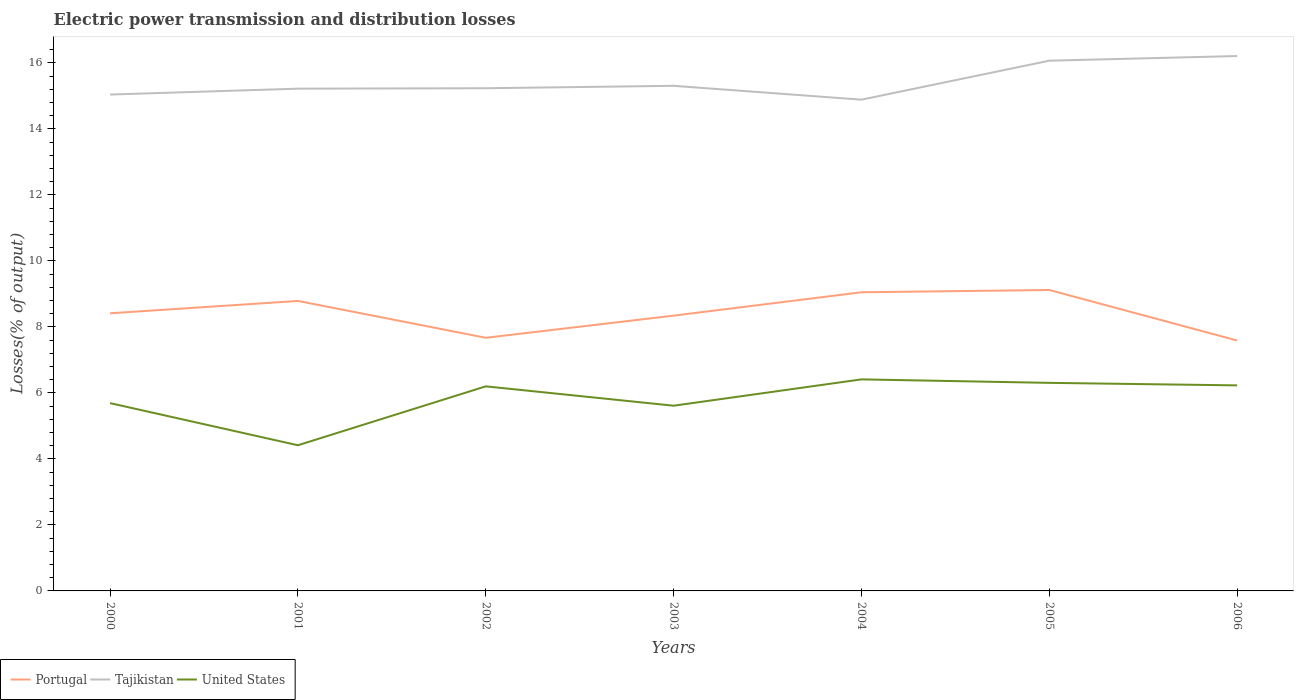Is the number of lines equal to the number of legend labels?
Ensure brevity in your answer.  Yes. Across all years, what is the maximum electric power transmission and distribution losses in United States?
Your answer should be compact. 4.41. What is the total electric power transmission and distribution losses in Portugal in the graph?
Your answer should be compact. -0.64. What is the difference between the highest and the second highest electric power transmission and distribution losses in Portugal?
Provide a succinct answer. 1.53. What is the difference between the highest and the lowest electric power transmission and distribution losses in Portugal?
Ensure brevity in your answer.  3. How many lines are there?
Your answer should be compact. 3. Does the graph contain any zero values?
Offer a terse response. No. Does the graph contain grids?
Ensure brevity in your answer.  No. Where does the legend appear in the graph?
Provide a succinct answer. Bottom left. How many legend labels are there?
Your answer should be very brief. 3. What is the title of the graph?
Provide a short and direct response. Electric power transmission and distribution losses. What is the label or title of the Y-axis?
Make the answer very short. Losses(% of output). What is the Losses(% of output) in Portugal in 2000?
Your answer should be compact. 8.41. What is the Losses(% of output) of Tajikistan in 2000?
Offer a very short reply. 15.04. What is the Losses(% of output) of United States in 2000?
Give a very brief answer. 5.69. What is the Losses(% of output) in Portugal in 2001?
Keep it short and to the point. 8.79. What is the Losses(% of output) in Tajikistan in 2001?
Provide a succinct answer. 15.22. What is the Losses(% of output) in United States in 2001?
Offer a very short reply. 4.41. What is the Losses(% of output) of Portugal in 2002?
Provide a succinct answer. 7.67. What is the Losses(% of output) of Tajikistan in 2002?
Keep it short and to the point. 15.23. What is the Losses(% of output) of United States in 2002?
Your response must be concise. 6.2. What is the Losses(% of output) of Portugal in 2003?
Your response must be concise. 8.34. What is the Losses(% of output) of Tajikistan in 2003?
Provide a succinct answer. 15.31. What is the Losses(% of output) of United States in 2003?
Your answer should be compact. 5.61. What is the Losses(% of output) in Portugal in 2004?
Provide a succinct answer. 9.05. What is the Losses(% of output) of Tajikistan in 2004?
Give a very brief answer. 14.89. What is the Losses(% of output) of United States in 2004?
Provide a short and direct response. 6.41. What is the Losses(% of output) in Portugal in 2005?
Your response must be concise. 9.12. What is the Losses(% of output) of Tajikistan in 2005?
Provide a short and direct response. 16.07. What is the Losses(% of output) of United States in 2005?
Ensure brevity in your answer.  6.31. What is the Losses(% of output) in Portugal in 2006?
Provide a succinct answer. 7.59. What is the Losses(% of output) of Tajikistan in 2006?
Provide a succinct answer. 16.21. What is the Losses(% of output) of United States in 2006?
Provide a succinct answer. 6.23. Across all years, what is the maximum Losses(% of output) in Portugal?
Your response must be concise. 9.12. Across all years, what is the maximum Losses(% of output) of Tajikistan?
Offer a very short reply. 16.21. Across all years, what is the maximum Losses(% of output) of United States?
Your answer should be compact. 6.41. Across all years, what is the minimum Losses(% of output) of Portugal?
Ensure brevity in your answer.  7.59. Across all years, what is the minimum Losses(% of output) of Tajikistan?
Give a very brief answer. 14.89. Across all years, what is the minimum Losses(% of output) in United States?
Give a very brief answer. 4.41. What is the total Losses(% of output) of Portugal in the graph?
Provide a short and direct response. 58.97. What is the total Losses(% of output) in Tajikistan in the graph?
Your answer should be very brief. 107.97. What is the total Losses(% of output) in United States in the graph?
Provide a short and direct response. 40.86. What is the difference between the Losses(% of output) of Portugal in 2000 and that in 2001?
Ensure brevity in your answer.  -0.37. What is the difference between the Losses(% of output) of Tajikistan in 2000 and that in 2001?
Give a very brief answer. -0.18. What is the difference between the Losses(% of output) of United States in 2000 and that in 2001?
Keep it short and to the point. 1.28. What is the difference between the Losses(% of output) of Portugal in 2000 and that in 2002?
Offer a very short reply. 0.74. What is the difference between the Losses(% of output) of Tajikistan in 2000 and that in 2002?
Your answer should be compact. -0.19. What is the difference between the Losses(% of output) in United States in 2000 and that in 2002?
Ensure brevity in your answer.  -0.51. What is the difference between the Losses(% of output) of Portugal in 2000 and that in 2003?
Offer a terse response. 0.07. What is the difference between the Losses(% of output) in Tajikistan in 2000 and that in 2003?
Give a very brief answer. -0.27. What is the difference between the Losses(% of output) in United States in 2000 and that in 2003?
Ensure brevity in your answer.  0.08. What is the difference between the Losses(% of output) in Portugal in 2000 and that in 2004?
Provide a short and direct response. -0.64. What is the difference between the Losses(% of output) in Tajikistan in 2000 and that in 2004?
Keep it short and to the point. 0.15. What is the difference between the Losses(% of output) in United States in 2000 and that in 2004?
Your response must be concise. -0.72. What is the difference between the Losses(% of output) in Portugal in 2000 and that in 2005?
Give a very brief answer. -0.71. What is the difference between the Losses(% of output) of Tajikistan in 2000 and that in 2005?
Your answer should be compact. -1.03. What is the difference between the Losses(% of output) of United States in 2000 and that in 2005?
Your answer should be very brief. -0.61. What is the difference between the Losses(% of output) of Portugal in 2000 and that in 2006?
Provide a succinct answer. 0.83. What is the difference between the Losses(% of output) in Tajikistan in 2000 and that in 2006?
Offer a very short reply. -1.17. What is the difference between the Losses(% of output) of United States in 2000 and that in 2006?
Your answer should be compact. -0.54. What is the difference between the Losses(% of output) of Portugal in 2001 and that in 2002?
Ensure brevity in your answer.  1.12. What is the difference between the Losses(% of output) in Tajikistan in 2001 and that in 2002?
Offer a very short reply. -0.01. What is the difference between the Losses(% of output) of United States in 2001 and that in 2002?
Your answer should be very brief. -1.79. What is the difference between the Losses(% of output) of Portugal in 2001 and that in 2003?
Your answer should be very brief. 0.45. What is the difference between the Losses(% of output) in Tajikistan in 2001 and that in 2003?
Your response must be concise. -0.09. What is the difference between the Losses(% of output) in United States in 2001 and that in 2003?
Provide a short and direct response. -1.2. What is the difference between the Losses(% of output) of Portugal in 2001 and that in 2004?
Give a very brief answer. -0.26. What is the difference between the Losses(% of output) of Tajikistan in 2001 and that in 2004?
Make the answer very short. 0.33. What is the difference between the Losses(% of output) of United States in 2001 and that in 2004?
Offer a very short reply. -2. What is the difference between the Losses(% of output) of Portugal in 2001 and that in 2005?
Make the answer very short. -0.33. What is the difference between the Losses(% of output) of Tajikistan in 2001 and that in 2005?
Keep it short and to the point. -0.85. What is the difference between the Losses(% of output) in United States in 2001 and that in 2005?
Offer a terse response. -1.89. What is the difference between the Losses(% of output) in Portugal in 2001 and that in 2006?
Keep it short and to the point. 1.2. What is the difference between the Losses(% of output) in Tajikistan in 2001 and that in 2006?
Your answer should be compact. -0.99. What is the difference between the Losses(% of output) of United States in 2001 and that in 2006?
Your answer should be very brief. -1.81. What is the difference between the Losses(% of output) of Portugal in 2002 and that in 2003?
Offer a very short reply. -0.67. What is the difference between the Losses(% of output) of Tajikistan in 2002 and that in 2003?
Give a very brief answer. -0.07. What is the difference between the Losses(% of output) of United States in 2002 and that in 2003?
Keep it short and to the point. 0.59. What is the difference between the Losses(% of output) in Portugal in 2002 and that in 2004?
Offer a terse response. -1.38. What is the difference between the Losses(% of output) of Tajikistan in 2002 and that in 2004?
Give a very brief answer. 0.35. What is the difference between the Losses(% of output) of United States in 2002 and that in 2004?
Your response must be concise. -0.21. What is the difference between the Losses(% of output) in Portugal in 2002 and that in 2005?
Provide a short and direct response. -1.45. What is the difference between the Losses(% of output) in Tajikistan in 2002 and that in 2005?
Your answer should be compact. -0.83. What is the difference between the Losses(% of output) of United States in 2002 and that in 2005?
Ensure brevity in your answer.  -0.11. What is the difference between the Losses(% of output) of Portugal in 2002 and that in 2006?
Make the answer very short. 0.08. What is the difference between the Losses(% of output) of Tajikistan in 2002 and that in 2006?
Make the answer very short. -0.98. What is the difference between the Losses(% of output) in United States in 2002 and that in 2006?
Offer a terse response. -0.03. What is the difference between the Losses(% of output) of Portugal in 2003 and that in 2004?
Offer a very short reply. -0.71. What is the difference between the Losses(% of output) in Tajikistan in 2003 and that in 2004?
Offer a very short reply. 0.42. What is the difference between the Losses(% of output) in United States in 2003 and that in 2004?
Offer a terse response. -0.8. What is the difference between the Losses(% of output) in Portugal in 2003 and that in 2005?
Ensure brevity in your answer.  -0.78. What is the difference between the Losses(% of output) in Tajikistan in 2003 and that in 2005?
Provide a short and direct response. -0.76. What is the difference between the Losses(% of output) of United States in 2003 and that in 2005?
Give a very brief answer. -0.69. What is the difference between the Losses(% of output) of Portugal in 2003 and that in 2006?
Offer a very short reply. 0.75. What is the difference between the Losses(% of output) of Tajikistan in 2003 and that in 2006?
Ensure brevity in your answer.  -0.9. What is the difference between the Losses(% of output) of United States in 2003 and that in 2006?
Make the answer very short. -0.62. What is the difference between the Losses(% of output) of Portugal in 2004 and that in 2005?
Keep it short and to the point. -0.07. What is the difference between the Losses(% of output) in Tajikistan in 2004 and that in 2005?
Your answer should be compact. -1.18. What is the difference between the Losses(% of output) of United States in 2004 and that in 2005?
Keep it short and to the point. 0.11. What is the difference between the Losses(% of output) of Portugal in 2004 and that in 2006?
Offer a very short reply. 1.46. What is the difference between the Losses(% of output) in Tajikistan in 2004 and that in 2006?
Provide a succinct answer. -1.32. What is the difference between the Losses(% of output) of United States in 2004 and that in 2006?
Your response must be concise. 0.18. What is the difference between the Losses(% of output) in Portugal in 2005 and that in 2006?
Ensure brevity in your answer.  1.53. What is the difference between the Losses(% of output) of Tajikistan in 2005 and that in 2006?
Provide a short and direct response. -0.14. What is the difference between the Losses(% of output) in United States in 2005 and that in 2006?
Give a very brief answer. 0.08. What is the difference between the Losses(% of output) of Portugal in 2000 and the Losses(% of output) of Tajikistan in 2001?
Make the answer very short. -6.81. What is the difference between the Losses(% of output) in Portugal in 2000 and the Losses(% of output) in United States in 2001?
Your answer should be very brief. 4. What is the difference between the Losses(% of output) in Tajikistan in 2000 and the Losses(% of output) in United States in 2001?
Offer a very short reply. 10.63. What is the difference between the Losses(% of output) of Portugal in 2000 and the Losses(% of output) of Tajikistan in 2002?
Your answer should be compact. -6.82. What is the difference between the Losses(% of output) of Portugal in 2000 and the Losses(% of output) of United States in 2002?
Your answer should be compact. 2.21. What is the difference between the Losses(% of output) of Tajikistan in 2000 and the Losses(% of output) of United States in 2002?
Your answer should be very brief. 8.84. What is the difference between the Losses(% of output) of Portugal in 2000 and the Losses(% of output) of Tajikistan in 2003?
Your answer should be very brief. -6.89. What is the difference between the Losses(% of output) in Portugal in 2000 and the Losses(% of output) in United States in 2003?
Provide a short and direct response. 2.8. What is the difference between the Losses(% of output) in Tajikistan in 2000 and the Losses(% of output) in United States in 2003?
Provide a short and direct response. 9.43. What is the difference between the Losses(% of output) of Portugal in 2000 and the Losses(% of output) of Tajikistan in 2004?
Keep it short and to the point. -6.47. What is the difference between the Losses(% of output) in Portugal in 2000 and the Losses(% of output) in United States in 2004?
Provide a short and direct response. 2. What is the difference between the Losses(% of output) of Tajikistan in 2000 and the Losses(% of output) of United States in 2004?
Provide a short and direct response. 8.63. What is the difference between the Losses(% of output) of Portugal in 2000 and the Losses(% of output) of Tajikistan in 2005?
Provide a short and direct response. -7.65. What is the difference between the Losses(% of output) in Portugal in 2000 and the Losses(% of output) in United States in 2005?
Give a very brief answer. 2.11. What is the difference between the Losses(% of output) in Tajikistan in 2000 and the Losses(% of output) in United States in 2005?
Offer a very short reply. 8.74. What is the difference between the Losses(% of output) in Portugal in 2000 and the Losses(% of output) in Tajikistan in 2006?
Give a very brief answer. -7.8. What is the difference between the Losses(% of output) of Portugal in 2000 and the Losses(% of output) of United States in 2006?
Your answer should be very brief. 2.18. What is the difference between the Losses(% of output) of Tajikistan in 2000 and the Losses(% of output) of United States in 2006?
Your answer should be compact. 8.81. What is the difference between the Losses(% of output) in Portugal in 2001 and the Losses(% of output) in Tajikistan in 2002?
Offer a terse response. -6.45. What is the difference between the Losses(% of output) of Portugal in 2001 and the Losses(% of output) of United States in 2002?
Offer a very short reply. 2.59. What is the difference between the Losses(% of output) in Tajikistan in 2001 and the Losses(% of output) in United States in 2002?
Offer a terse response. 9.02. What is the difference between the Losses(% of output) in Portugal in 2001 and the Losses(% of output) in Tajikistan in 2003?
Give a very brief answer. -6.52. What is the difference between the Losses(% of output) in Portugal in 2001 and the Losses(% of output) in United States in 2003?
Your response must be concise. 3.17. What is the difference between the Losses(% of output) of Tajikistan in 2001 and the Losses(% of output) of United States in 2003?
Offer a very short reply. 9.61. What is the difference between the Losses(% of output) in Portugal in 2001 and the Losses(% of output) in Tajikistan in 2004?
Make the answer very short. -6.1. What is the difference between the Losses(% of output) in Portugal in 2001 and the Losses(% of output) in United States in 2004?
Make the answer very short. 2.38. What is the difference between the Losses(% of output) of Tajikistan in 2001 and the Losses(% of output) of United States in 2004?
Offer a very short reply. 8.81. What is the difference between the Losses(% of output) of Portugal in 2001 and the Losses(% of output) of Tajikistan in 2005?
Offer a very short reply. -7.28. What is the difference between the Losses(% of output) of Portugal in 2001 and the Losses(% of output) of United States in 2005?
Your answer should be very brief. 2.48. What is the difference between the Losses(% of output) in Tajikistan in 2001 and the Losses(% of output) in United States in 2005?
Give a very brief answer. 8.92. What is the difference between the Losses(% of output) in Portugal in 2001 and the Losses(% of output) in Tajikistan in 2006?
Your answer should be very brief. -7.42. What is the difference between the Losses(% of output) in Portugal in 2001 and the Losses(% of output) in United States in 2006?
Offer a very short reply. 2.56. What is the difference between the Losses(% of output) of Tajikistan in 2001 and the Losses(% of output) of United States in 2006?
Give a very brief answer. 8.99. What is the difference between the Losses(% of output) of Portugal in 2002 and the Losses(% of output) of Tajikistan in 2003?
Your answer should be compact. -7.64. What is the difference between the Losses(% of output) in Portugal in 2002 and the Losses(% of output) in United States in 2003?
Provide a succinct answer. 2.06. What is the difference between the Losses(% of output) in Tajikistan in 2002 and the Losses(% of output) in United States in 2003?
Make the answer very short. 9.62. What is the difference between the Losses(% of output) in Portugal in 2002 and the Losses(% of output) in Tajikistan in 2004?
Offer a very short reply. -7.22. What is the difference between the Losses(% of output) of Portugal in 2002 and the Losses(% of output) of United States in 2004?
Offer a very short reply. 1.26. What is the difference between the Losses(% of output) in Tajikistan in 2002 and the Losses(% of output) in United States in 2004?
Offer a terse response. 8.82. What is the difference between the Losses(% of output) of Portugal in 2002 and the Losses(% of output) of Tajikistan in 2005?
Make the answer very short. -8.4. What is the difference between the Losses(% of output) in Portugal in 2002 and the Losses(% of output) in United States in 2005?
Give a very brief answer. 1.37. What is the difference between the Losses(% of output) in Tajikistan in 2002 and the Losses(% of output) in United States in 2005?
Provide a short and direct response. 8.93. What is the difference between the Losses(% of output) of Portugal in 2002 and the Losses(% of output) of Tajikistan in 2006?
Ensure brevity in your answer.  -8.54. What is the difference between the Losses(% of output) of Portugal in 2002 and the Losses(% of output) of United States in 2006?
Your answer should be compact. 1.44. What is the difference between the Losses(% of output) in Tajikistan in 2002 and the Losses(% of output) in United States in 2006?
Offer a terse response. 9. What is the difference between the Losses(% of output) in Portugal in 2003 and the Losses(% of output) in Tajikistan in 2004?
Ensure brevity in your answer.  -6.54. What is the difference between the Losses(% of output) of Portugal in 2003 and the Losses(% of output) of United States in 2004?
Give a very brief answer. 1.93. What is the difference between the Losses(% of output) of Tajikistan in 2003 and the Losses(% of output) of United States in 2004?
Offer a very short reply. 8.9. What is the difference between the Losses(% of output) in Portugal in 2003 and the Losses(% of output) in Tajikistan in 2005?
Make the answer very short. -7.73. What is the difference between the Losses(% of output) in Portugal in 2003 and the Losses(% of output) in United States in 2005?
Offer a terse response. 2.04. What is the difference between the Losses(% of output) of Tajikistan in 2003 and the Losses(% of output) of United States in 2005?
Your response must be concise. 9. What is the difference between the Losses(% of output) in Portugal in 2003 and the Losses(% of output) in Tajikistan in 2006?
Your answer should be very brief. -7.87. What is the difference between the Losses(% of output) of Portugal in 2003 and the Losses(% of output) of United States in 2006?
Keep it short and to the point. 2.11. What is the difference between the Losses(% of output) in Tajikistan in 2003 and the Losses(% of output) in United States in 2006?
Give a very brief answer. 9.08. What is the difference between the Losses(% of output) of Portugal in 2004 and the Losses(% of output) of Tajikistan in 2005?
Keep it short and to the point. -7.02. What is the difference between the Losses(% of output) in Portugal in 2004 and the Losses(% of output) in United States in 2005?
Ensure brevity in your answer.  2.75. What is the difference between the Losses(% of output) in Tajikistan in 2004 and the Losses(% of output) in United States in 2005?
Give a very brief answer. 8.58. What is the difference between the Losses(% of output) in Portugal in 2004 and the Losses(% of output) in Tajikistan in 2006?
Your answer should be very brief. -7.16. What is the difference between the Losses(% of output) of Portugal in 2004 and the Losses(% of output) of United States in 2006?
Your answer should be very brief. 2.82. What is the difference between the Losses(% of output) of Tajikistan in 2004 and the Losses(% of output) of United States in 2006?
Offer a terse response. 8.66. What is the difference between the Losses(% of output) of Portugal in 2005 and the Losses(% of output) of Tajikistan in 2006?
Make the answer very short. -7.09. What is the difference between the Losses(% of output) in Portugal in 2005 and the Losses(% of output) in United States in 2006?
Offer a very short reply. 2.89. What is the difference between the Losses(% of output) in Tajikistan in 2005 and the Losses(% of output) in United States in 2006?
Your answer should be compact. 9.84. What is the average Losses(% of output) of Portugal per year?
Your answer should be very brief. 8.42. What is the average Losses(% of output) in Tajikistan per year?
Provide a short and direct response. 15.42. What is the average Losses(% of output) in United States per year?
Offer a very short reply. 5.84. In the year 2000, what is the difference between the Losses(% of output) of Portugal and Losses(% of output) of Tajikistan?
Your answer should be very brief. -6.63. In the year 2000, what is the difference between the Losses(% of output) in Portugal and Losses(% of output) in United States?
Keep it short and to the point. 2.72. In the year 2000, what is the difference between the Losses(% of output) of Tajikistan and Losses(% of output) of United States?
Offer a terse response. 9.35. In the year 2001, what is the difference between the Losses(% of output) in Portugal and Losses(% of output) in Tajikistan?
Offer a very short reply. -6.43. In the year 2001, what is the difference between the Losses(% of output) in Portugal and Losses(% of output) in United States?
Your response must be concise. 4.37. In the year 2001, what is the difference between the Losses(% of output) of Tajikistan and Losses(% of output) of United States?
Ensure brevity in your answer.  10.81. In the year 2002, what is the difference between the Losses(% of output) of Portugal and Losses(% of output) of Tajikistan?
Your answer should be compact. -7.56. In the year 2002, what is the difference between the Losses(% of output) in Portugal and Losses(% of output) in United States?
Offer a very short reply. 1.47. In the year 2002, what is the difference between the Losses(% of output) of Tajikistan and Losses(% of output) of United States?
Keep it short and to the point. 9.03. In the year 2003, what is the difference between the Losses(% of output) in Portugal and Losses(% of output) in Tajikistan?
Provide a short and direct response. -6.96. In the year 2003, what is the difference between the Losses(% of output) of Portugal and Losses(% of output) of United States?
Provide a succinct answer. 2.73. In the year 2003, what is the difference between the Losses(% of output) in Tajikistan and Losses(% of output) in United States?
Your response must be concise. 9.69. In the year 2004, what is the difference between the Losses(% of output) of Portugal and Losses(% of output) of Tajikistan?
Your answer should be very brief. -5.84. In the year 2004, what is the difference between the Losses(% of output) in Portugal and Losses(% of output) in United States?
Provide a short and direct response. 2.64. In the year 2004, what is the difference between the Losses(% of output) of Tajikistan and Losses(% of output) of United States?
Keep it short and to the point. 8.48. In the year 2005, what is the difference between the Losses(% of output) in Portugal and Losses(% of output) in Tajikistan?
Your answer should be very brief. -6.95. In the year 2005, what is the difference between the Losses(% of output) of Portugal and Losses(% of output) of United States?
Your response must be concise. 2.81. In the year 2005, what is the difference between the Losses(% of output) of Tajikistan and Losses(% of output) of United States?
Keep it short and to the point. 9.76. In the year 2006, what is the difference between the Losses(% of output) in Portugal and Losses(% of output) in Tajikistan?
Keep it short and to the point. -8.62. In the year 2006, what is the difference between the Losses(% of output) of Portugal and Losses(% of output) of United States?
Keep it short and to the point. 1.36. In the year 2006, what is the difference between the Losses(% of output) in Tajikistan and Losses(% of output) in United States?
Make the answer very short. 9.98. What is the ratio of the Losses(% of output) of Portugal in 2000 to that in 2001?
Your answer should be compact. 0.96. What is the ratio of the Losses(% of output) of Tajikistan in 2000 to that in 2001?
Provide a short and direct response. 0.99. What is the ratio of the Losses(% of output) of United States in 2000 to that in 2001?
Keep it short and to the point. 1.29. What is the ratio of the Losses(% of output) of Portugal in 2000 to that in 2002?
Offer a very short reply. 1.1. What is the ratio of the Losses(% of output) in Tajikistan in 2000 to that in 2002?
Ensure brevity in your answer.  0.99. What is the ratio of the Losses(% of output) of United States in 2000 to that in 2002?
Keep it short and to the point. 0.92. What is the ratio of the Losses(% of output) of Portugal in 2000 to that in 2003?
Make the answer very short. 1.01. What is the ratio of the Losses(% of output) in Tajikistan in 2000 to that in 2003?
Provide a succinct answer. 0.98. What is the ratio of the Losses(% of output) in United States in 2000 to that in 2003?
Your answer should be very brief. 1.01. What is the ratio of the Losses(% of output) of Portugal in 2000 to that in 2004?
Your response must be concise. 0.93. What is the ratio of the Losses(% of output) in Tajikistan in 2000 to that in 2004?
Your response must be concise. 1.01. What is the ratio of the Losses(% of output) in United States in 2000 to that in 2004?
Keep it short and to the point. 0.89. What is the ratio of the Losses(% of output) of Portugal in 2000 to that in 2005?
Your response must be concise. 0.92. What is the ratio of the Losses(% of output) in Tajikistan in 2000 to that in 2005?
Provide a succinct answer. 0.94. What is the ratio of the Losses(% of output) in United States in 2000 to that in 2005?
Provide a short and direct response. 0.9. What is the ratio of the Losses(% of output) in Portugal in 2000 to that in 2006?
Your response must be concise. 1.11. What is the ratio of the Losses(% of output) of Tajikistan in 2000 to that in 2006?
Ensure brevity in your answer.  0.93. What is the ratio of the Losses(% of output) of United States in 2000 to that in 2006?
Provide a succinct answer. 0.91. What is the ratio of the Losses(% of output) of Portugal in 2001 to that in 2002?
Provide a short and direct response. 1.15. What is the ratio of the Losses(% of output) in Tajikistan in 2001 to that in 2002?
Provide a short and direct response. 1. What is the ratio of the Losses(% of output) of United States in 2001 to that in 2002?
Your answer should be very brief. 0.71. What is the ratio of the Losses(% of output) in Portugal in 2001 to that in 2003?
Your answer should be very brief. 1.05. What is the ratio of the Losses(% of output) in United States in 2001 to that in 2003?
Provide a short and direct response. 0.79. What is the ratio of the Losses(% of output) of Portugal in 2001 to that in 2004?
Offer a terse response. 0.97. What is the ratio of the Losses(% of output) of Tajikistan in 2001 to that in 2004?
Offer a very short reply. 1.02. What is the ratio of the Losses(% of output) of United States in 2001 to that in 2004?
Give a very brief answer. 0.69. What is the ratio of the Losses(% of output) of Portugal in 2001 to that in 2005?
Provide a short and direct response. 0.96. What is the ratio of the Losses(% of output) of Tajikistan in 2001 to that in 2005?
Make the answer very short. 0.95. What is the ratio of the Losses(% of output) in United States in 2001 to that in 2005?
Keep it short and to the point. 0.7. What is the ratio of the Losses(% of output) in Portugal in 2001 to that in 2006?
Your response must be concise. 1.16. What is the ratio of the Losses(% of output) in Tajikistan in 2001 to that in 2006?
Your answer should be very brief. 0.94. What is the ratio of the Losses(% of output) in United States in 2001 to that in 2006?
Your answer should be compact. 0.71. What is the ratio of the Losses(% of output) in Portugal in 2002 to that in 2003?
Provide a succinct answer. 0.92. What is the ratio of the Losses(% of output) in Tajikistan in 2002 to that in 2003?
Offer a terse response. 1. What is the ratio of the Losses(% of output) in United States in 2002 to that in 2003?
Offer a very short reply. 1.1. What is the ratio of the Losses(% of output) of Portugal in 2002 to that in 2004?
Give a very brief answer. 0.85. What is the ratio of the Losses(% of output) of Tajikistan in 2002 to that in 2004?
Your response must be concise. 1.02. What is the ratio of the Losses(% of output) of United States in 2002 to that in 2004?
Your answer should be very brief. 0.97. What is the ratio of the Losses(% of output) in Portugal in 2002 to that in 2005?
Offer a terse response. 0.84. What is the ratio of the Losses(% of output) in Tajikistan in 2002 to that in 2005?
Give a very brief answer. 0.95. What is the ratio of the Losses(% of output) of United States in 2002 to that in 2005?
Give a very brief answer. 0.98. What is the ratio of the Losses(% of output) in Tajikistan in 2002 to that in 2006?
Provide a succinct answer. 0.94. What is the ratio of the Losses(% of output) of United States in 2002 to that in 2006?
Offer a terse response. 1. What is the ratio of the Losses(% of output) of Portugal in 2003 to that in 2004?
Offer a very short reply. 0.92. What is the ratio of the Losses(% of output) in Tajikistan in 2003 to that in 2004?
Keep it short and to the point. 1.03. What is the ratio of the Losses(% of output) of United States in 2003 to that in 2004?
Provide a short and direct response. 0.88. What is the ratio of the Losses(% of output) in Portugal in 2003 to that in 2005?
Keep it short and to the point. 0.91. What is the ratio of the Losses(% of output) in Tajikistan in 2003 to that in 2005?
Your answer should be compact. 0.95. What is the ratio of the Losses(% of output) of United States in 2003 to that in 2005?
Offer a terse response. 0.89. What is the ratio of the Losses(% of output) in Portugal in 2003 to that in 2006?
Your answer should be very brief. 1.1. What is the ratio of the Losses(% of output) in Tajikistan in 2003 to that in 2006?
Give a very brief answer. 0.94. What is the ratio of the Losses(% of output) in United States in 2003 to that in 2006?
Your answer should be compact. 0.9. What is the ratio of the Losses(% of output) of Tajikistan in 2004 to that in 2005?
Make the answer very short. 0.93. What is the ratio of the Losses(% of output) of United States in 2004 to that in 2005?
Provide a succinct answer. 1.02. What is the ratio of the Losses(% of output) in Portugal in 2004 to that in 2006?
Ensure brevity in your answer.  1.19. What is the ratio of the Losses(% of output) in Tajikistan in 2004 to that in 2006?
Provide a succinct answer. 0.92. What is the ratio of the Losses(% of output) of United States in 2004 to that in 2006?
Provide a short and direct response. 1.03. What is the ratio of the Losses(% of output) of Portugal in 2005 to that in 2006?
Provide a succinct answer. 1.2. What is the ratio of the Losses(% of output) in United States in 2005 to that in 2006?
Give a very brief answer. 1.01. What is the difference between the highest and the second highest Losses(% of output) in Portugal?
Your answer should be very brief. 0.07. What is the difference between the highest and the second highest Losses(% of output) of Tajikistan?
Provide a short and direct response. 0.14. What is the difference between the highest and the second highest Losses(% of output) in United States?
Offer a terse response. 0.11. What is the difference between the highest and the lowest Losses(% of output) of Portugal?
Your answer should be compact. 1.53. What is the difference between the highest and the lowest Losses(% of output) of Tajikistan?
Ensure brevity in your answer.  1.32. What is the difference between the highest and the lowest Losses(% of output) of United States?
Give a very brief answer. 2. 